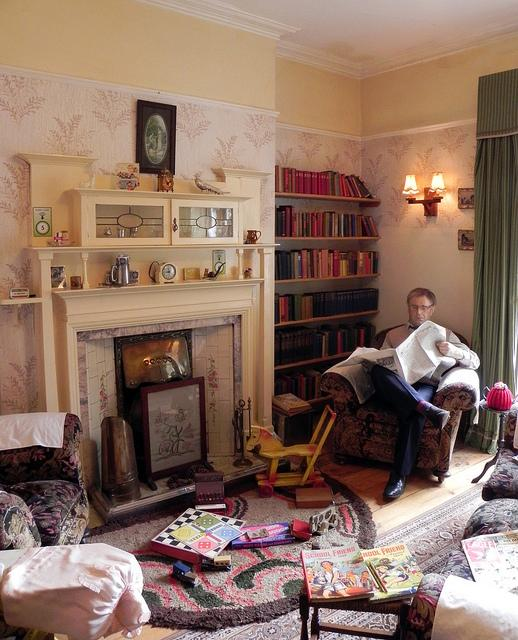How is the game laying on top of the chess board called?

Choices:
A) chess
B) monopoly
C) life
D) ludo ludo 